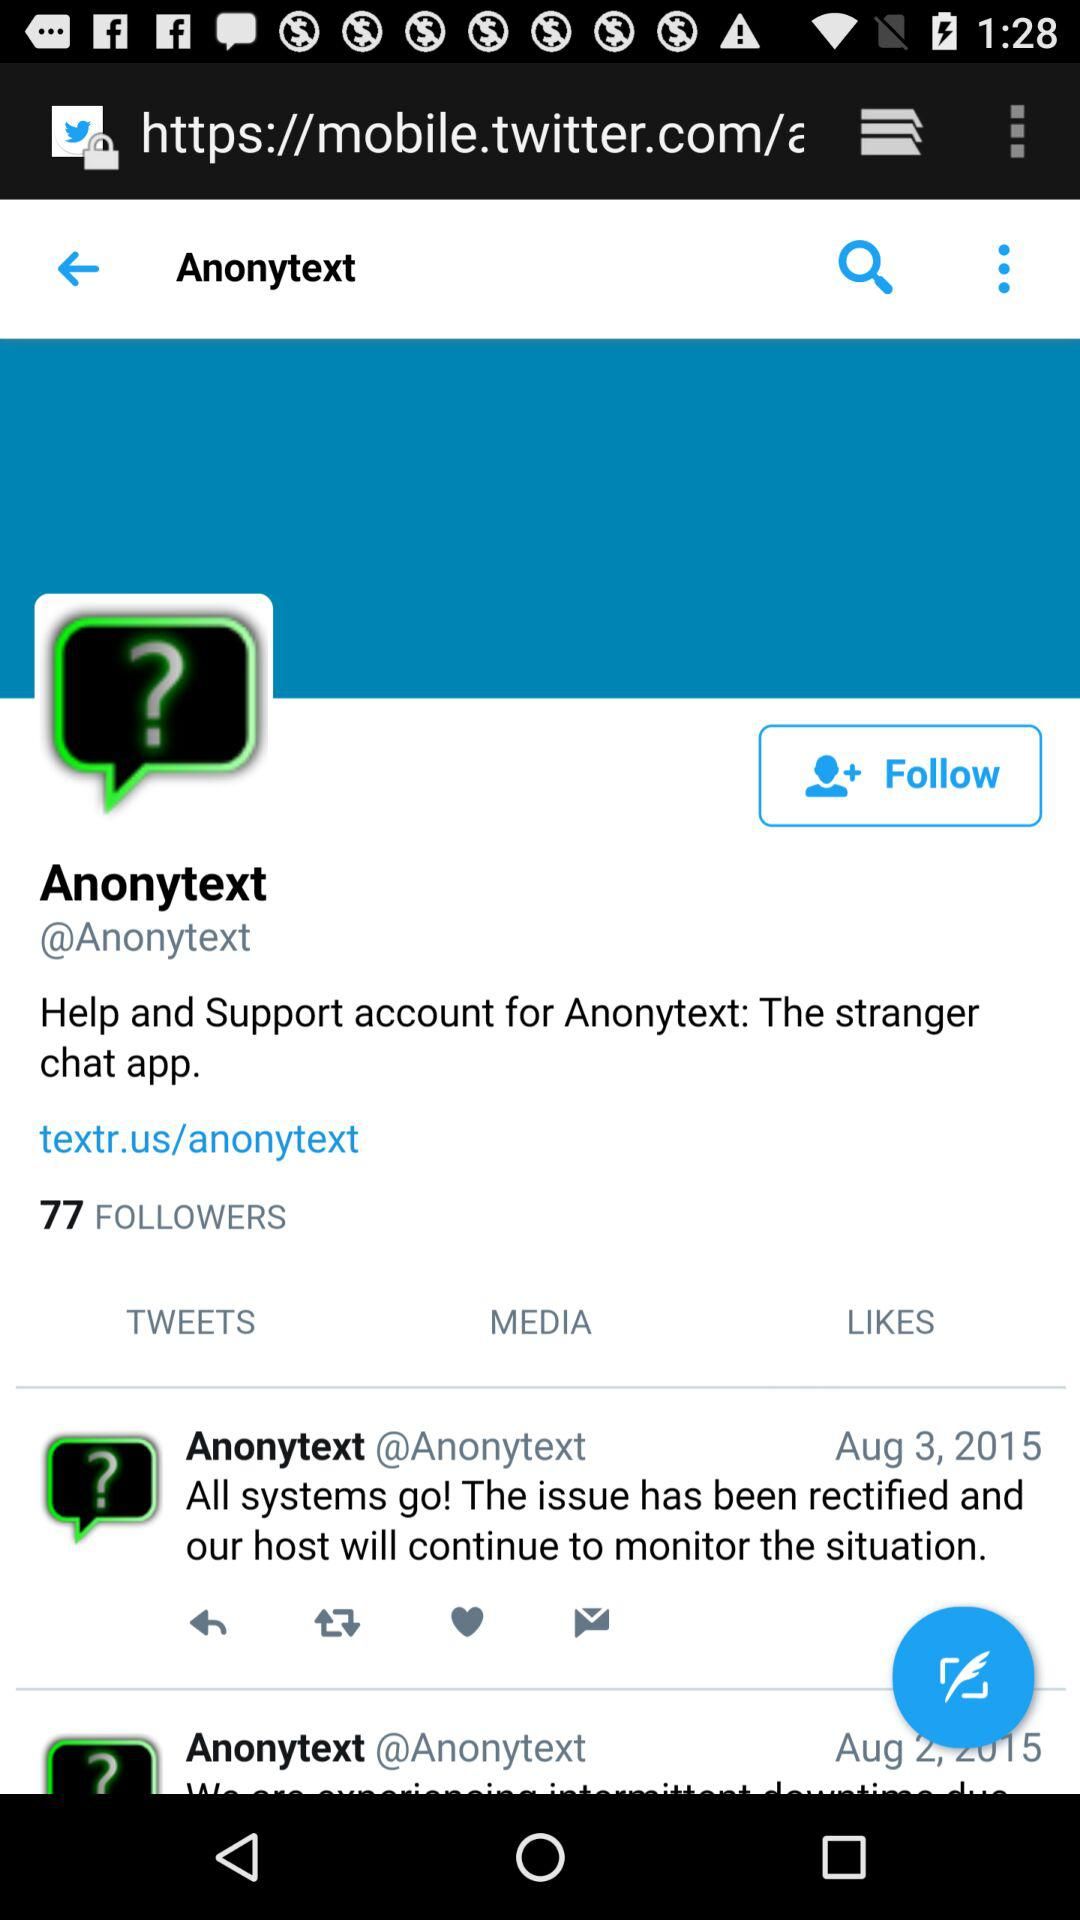How many followers does Anonytext have? Anonytext has 77 followers. 